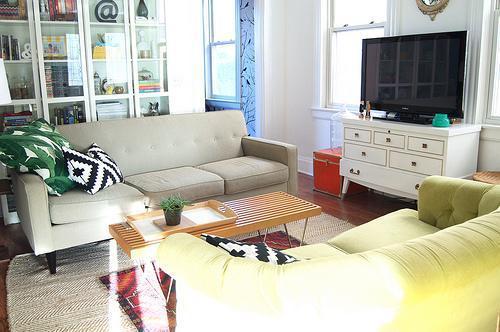How many tvs are pictured?
Give a very brief answer. 1. 